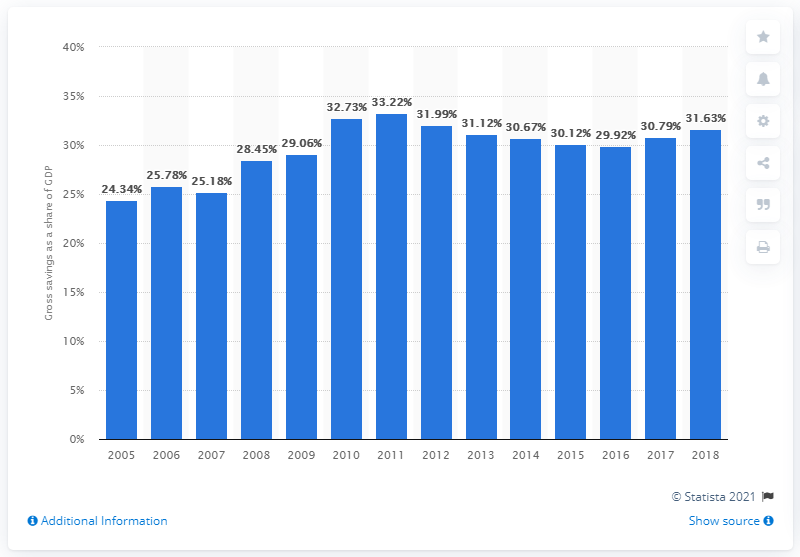Highlight a few significant elements in this photo. In 2018, Indonesia's gross savings represented 26.3% of the country's Gross Domestic Product (GDP), according to the Central Bureau of Statistics. 